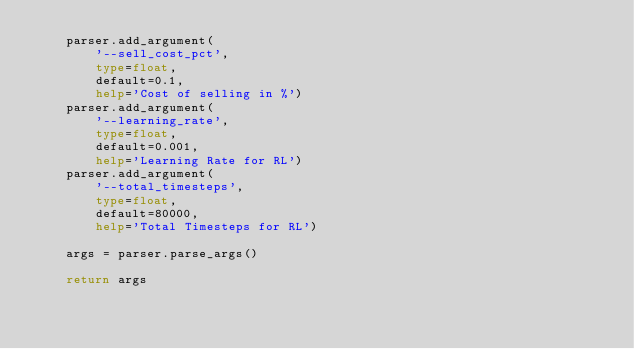Convert code to text. <code><loc_0><loc_0><loc_500><loc_500><_Python_>    parser.add_argument(
        '--sell_cost_pct',
        type=float,
        default=0.1,
        help='Cost of selling in %')
    parser.add_argument(
        '--learning_rate',
        type=float,
        default=0.001,
        help='Learning Rate for RL')
    parser.add_argument(
        '--total_timesteps',
        type=float,
        default=80000,
        help='Total Timesteps for RL')
    
    args = parser.parse_args()

    return args
</code> 